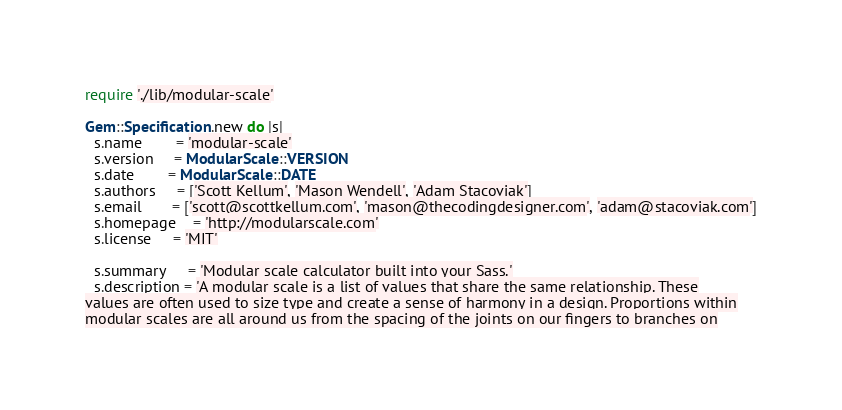<code> <loc_0><loc_0><loc_500><loc_500><_Ruby_>require './lib/modular-scale'

Gem::Specification.new do |s|
  s.name        = 'modular-scale'
  s.version     = ModularScale::VERSION
  s.date        = ModularScale::DATE
  s.authors     = ['Scott Kellum', 'Mason Wendell', 'Adam Stacoviak']
  s.email       = ['scott@scottkellum.com', 'mason@thecodingdesigner.com', 'adam@stacoviak.com']
  s.homepage    = 'http://modularscale.com'
  s.license     = 'MIT'

  s.summary     = 'Modular scale calculator built into your Sass.'
  s.description = 'A modular scale is a list of values that share the same relationship. These
values are often used to size type and create a sense of harmony in a design. Proportions within
modular scales are all around us from the spacing of the joints on our fingers to branches on</code> 